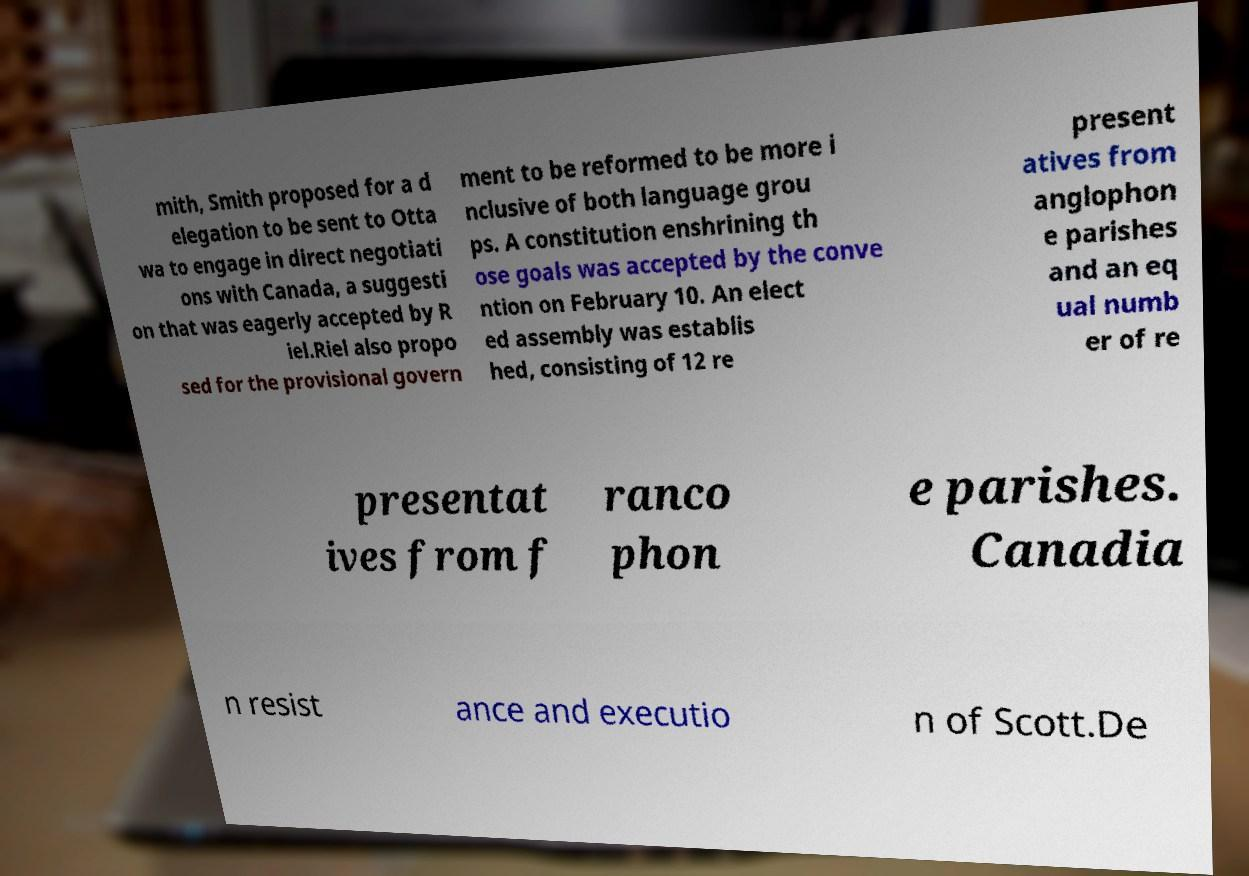For documentation purposes, I need the text within this image transcribed. Could you provide that? mith, Smith proposed for a d elegation to be sent to Otta wa to engage in direct negotiati ons with Canada, a suggesti on that was eagerly accepted by R iel.Riel also propo sed for the provisional govern ment to be reformed to be more i nclusive of both language grou ps. A constitution enshrining th ose goals was accepted by the conve ntion on February 10. An elect ed assembly was establis hed, consisting of 12 re present atives from anglophon e parishes and an eq ual numb er of re presentat ives from f ranco phon e parishes. Canadia n resist ance and executio n of Scott.De 